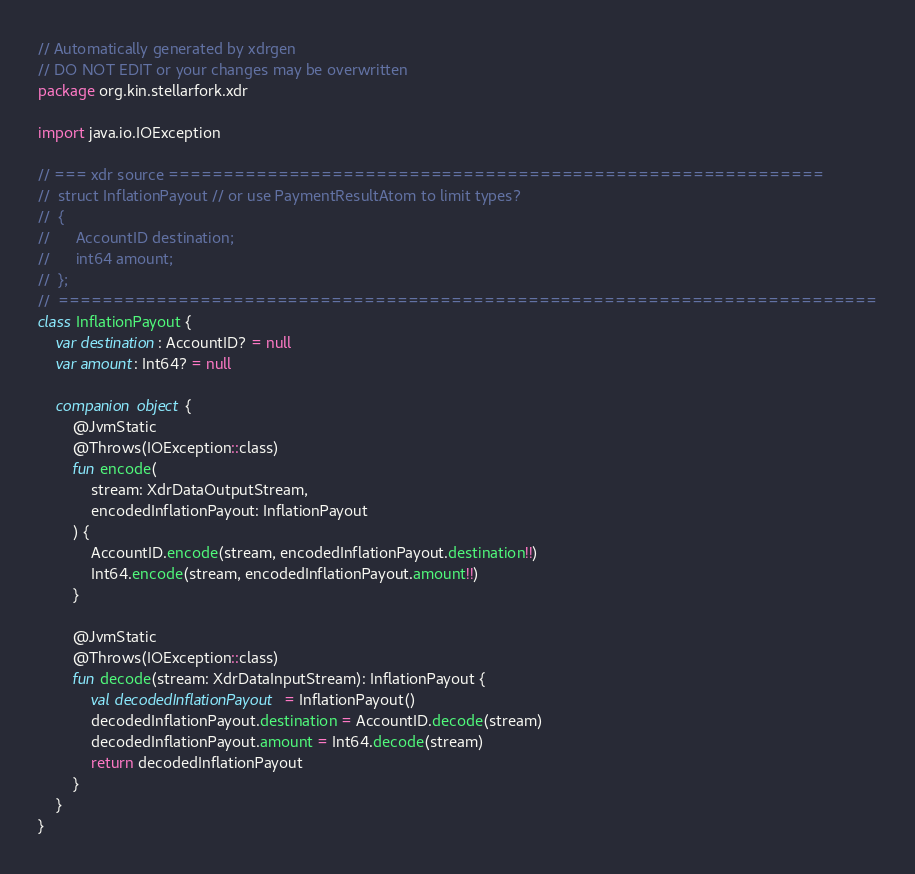<code> <loc_0><loc_0><loc_500><loc_500><_Kotlin_>// Automatically generated by xdrgen 
// DO NOT EDIT or your changes may be overwritten
package org.kin.stellarfork.xdr

import java.io.IOException

// === xdr source ============================================================
//  struct InflationPayout // or use PaymentResultAtom to limit types?
//  {
//      AccountID destination;
//      int64 amount;
//  };
//  ===========================================================================
class InflationPayout {
    var destination: AccountID? = null
    var amount: Int64? = null

    companion object {
        @JvmStatic
        @Throws(IOException::class)
        fun encode(
            stream: XdrDataOutputStream,
            encodedInflationPayout: InflationPayout
        ) {
            AccountID.encode(stream, encodedInflationPayout.destination!!)
            Int64.encode(stream, encodedInflationPayout.amount!!)
        }

        @JvmStatic
        @Throws(IOException::class)
        fun decode(stream: XdrDataInputStream): InflationPayout {
            val decodedInflationPayout = InflationPayout()
            decodedInflationPayout.destination = AccountID.decode(stream)
            decodedInflationPayout.amount = Int64.decode(stream)
            return decodedInflationPayout
        }
    }
}
</code> 